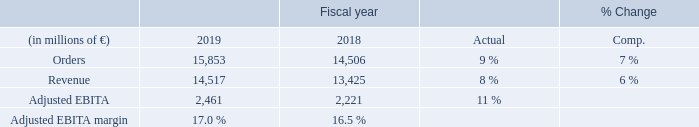Orders and revenue showed strong and similar development in fiscal 2019: clear growth; increases in all businesses led by the imaging business, and growth in all three reporting regions, notably including in China and in the U. S. which benefited from positive currency translation effects.
Adjusted EBITA was clearly up compared to fiscal 2018, with increases in the imaging and advance therapies businesses. The diagnostics business recorded lower Adjusted EBITA year-over-year due mainly to Combined Management Report 13 increases in costs related to its Atellica Solution platform. Severance charges were € 57 million in fiscal 2019 and € 96 million in fiscal 2018. The order backlog for Siemens Healthineers was € 18 billion at the end of the fiscal year, of which € 6 billion are
expected to be converted into revenue in fiscal 2020.
While demand in the markets served by Siemens Healthineers continued to grow in fiscal 2019, these markets also showed price pressure on new purchases and increased utilization rates for installed systems. All major served markets were in a healthy state, which contributed to a slightly higher market growth in Europe, C. I. S., Africa, Middle East and the Americas, most notably in the imaging and advanced therapies markets. The markets in Asia, Australia grew moderately. Markets in the U. S. showed slight growth in the imaging and clear growth in the advanced therapies
business, with continued moderate market growth in diagnostics.
Still, the U. S. market environment remained challenging
as pressure on reimbursement systems and the focus on more
extended utilization of equipment at customers’ sites persist.
Government initiatives and programs, together with a growing private market segment contributed to the re-stabilization and growth of markets in China. For the healthcare industry as a whole, the trend towards consolidation continued in fiscal 2019,
leading to higher utilization rates at customers’ sites, which are counterbalancing procedure volume growth in developed markets. Competition among the leading healthcare companies remained at a high level. For fiscal 2020, Siemens Healthineers expects the imaging and advanced therapies equipment markets to stay on a moderate growth path, while the diagnostics market is expected to grow clearly. Siemens Healthineers’ markets will continue to benefit from the long-term trends mentioned above, but are restricted by public spending constraints and by consolidation among healthcare providers.
On a geographic basis,
Siemens Healthineers expects markets in the region Asia, Australia to be the major growth driver. For China, Siemens Healthineers expects continuing strong growth due to rising government spending on healthcare, promotion of the private segment and wider access to healthcare services nationwide, pronounced effects of an aging population, and a growing incidence of chronic diseases. Growth in the U. S. is expected to be held back by continued pressure to increase utilization of existing equipment, reduced reimbursement rates and uncertainty about policies. For Europe, Siemens Healthineers expects slight growth, with a likely increased emphasis on equipment replacement and business with large customers such as hospital chains.
What was the reason for the increase in the Orders? Orders and revenue showed strong and similar development in fiscal 2019: clear growth; increases in all businesses led by the imaging business, and growth in all three reporting regions, notably including in china and in the u. s. which benefited from positive currency translation effects. What was the reason for the increase in the Adjusted EBITDA? Adjusted ebita was clearly up compared to fiscal 2018, with increases in the imaging and advance therapies businesses. the diagnostics business recorded lower adjusted ebita year-over-year due mainly to combined management report 13 increases in costs related to its atellica solution platform. How have the markets served by Siemens Healthineers responded in 2019? While demand in the markets served by siemens healthineers continued to grow in fiscal 2019, these markets also showed price pressure on new purchases and increased utilization rates for installed systems. What was the average orders for 2019 and 2018?
Answer scale should be: million. (15,853 + 14,506) / 2
Answer: 15179.5. What it the increase / (decrease) in revenue from 2018 to 2019?
Answer scale should be: million. 14,517 - 13,425
Answer: 1092. What is the increase / (decrease) in the Adjusted EBITDA margin from 2018 to 2019?
Answer scale should be: percent. 17.0% - 16.5%
Answer: 0.5. 